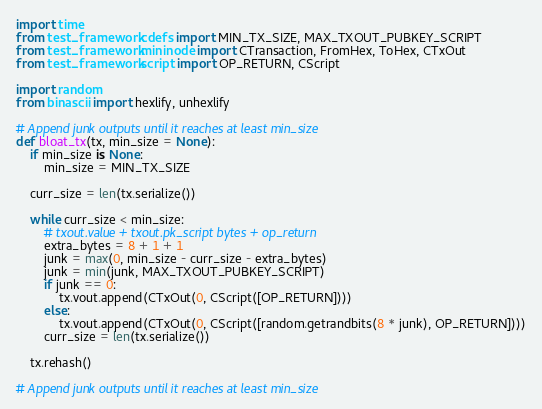<code> <loc_0><loc_0><loc_500><loc_500><_Python_>import time
from test_framework.cdefs import MIN_TX_SIZE, MAX_TXOUT_PUBKEY_SCRIPT
from test_framework.mininode import CTransaction, FromHex, ToHex, CTxOut
from test_framework.script import OP_RETURN, CScript

import random
from binascii import hexlify, unhexlify

# Append junk outputs until it reaches at least min_size
def bloat_tx(tx, min_size = None):
    if min_size is None:
        min_size = MIN_TX_SIZE

    curr_size = len(tx.serialize())

    while curr_size < min_size:
        # txout.value + txout.pk_script bytes + op_return
        extra_bytes = 8 + 1 + 1
        junk = max(0, min_size - curr_size - extra_bytes)
        junk = min(junk, MAX_TXOUT_PUBKEY_SCRIPT)
        if junk == 0:
            tx.vout.append(CTxOut(0, CScript([OP_RETURN])))
        else:
            tx.vout.append(CTxOut(0, CScript([random.getrandbits(8 * junk), OP_RETURN])))
        curr_size = len(tx.serialize())

    tx.rehash()

# Append junk outputs until it reaches at least min_size</code> 